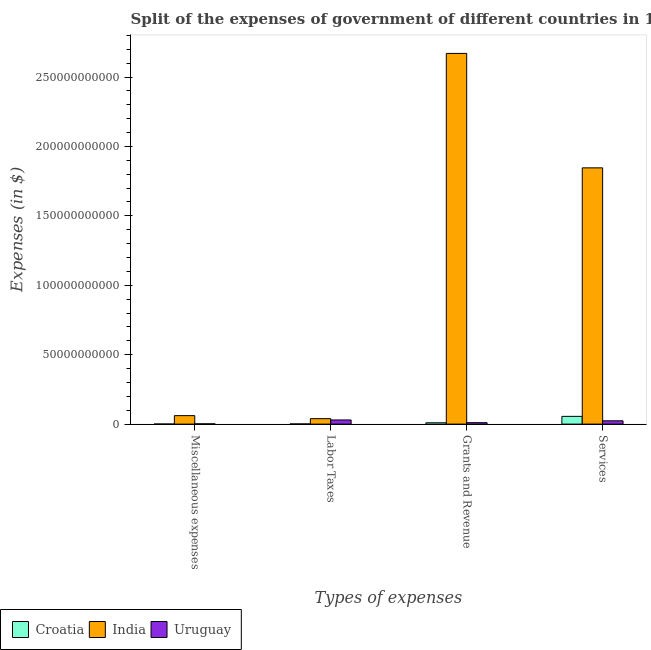How many different coloured bars are there?
Provide a short and direct response. 3. Are the number of bars on each tick of the X-axis equal?
Ensure brevity in your answer.  Yes. How many bars are there on the 1st tick from the right?
Provide a succinct answer. 3. What is the label of the 2nd group of bars from the left?
Provide a short and direct response. Labor Taxes. What is the amount spent on miscellaneous expenses in Uruguay?
Ensure brevity in your answer.  1.96e+08. Across all countries, what is the maximum amount spent on labor taxes?
Your response must be concise. 3.94e+09. Across all countries, what is the minimum amount spent on grants and revenue?
Your answer should be very brief. 9.59e+08. In which country was the amount spent on services minimum?
Your response must be concise. Uruguay. What is the total amount spent on services in the graph?
Offer a very short reply. 1.93e+11. What is the difference between the amount spent on miscellaneous expenses in India and that in Croatia?
Keep it short and to the point. 6.05e+09. What is the difference between the amount spent on services in Croatia and the amount spent on miscellaneous expenses in Uruguay?
Offer a very short reply. 5.39e+09. What is the average amount spent on services per country?
Keep it short and to the point. 6.42e+1. What is the difference between the amount spent on grants and revenue and amount spent on services in Croatia?
Provide a short and direct response. -4.62e+09. What is the ratio of the amount spent on miscellaneous expenses in Croatia to that in India?
Provide a succinct answer. 0.01. Is the amount spent on services in India less than that in Croatia?
Your answer should be very brief. No. Is the difference between the amount spent on services in Croatia and India greater than the difference between the amount spent on miscellaneous expenses in Croatia and India?
Offer a very short reply. No. What is the difference between the highest and the second highest amount spent on grants and revenue?
Your answer should be very brief. 2.66e+11. What is the difference between the highest and the lowest amount spent on labor taxes?
Your answer should be compact. 3.81e+09. In how many countries, is the amount spent on labor taxes greater than the average amount spent on labor taxes taken over all countries?
Keep it short and to the point. 2. Is it the case that in every country, the sum of the amount spent on miscellaneous expenses and amount spent on services is greater than the sum of amount spent on labor taxes and amount spent on grants and revenue?
Your answer should be compact. No. What does the 3rd bar from the left in Miscellaneous expenses represents?
Give a very brief answer. Uruguay. What does the 1st bar from the right in Grants and Revenue represents?
Your answer should be compact. Uruguay. How many bars are there?
Provide a short and direct response. 12. Are all the bars in the graph horizontal?
Make the answer very short. No. What is the difference between two consecutive major ticks on the Y-axis?
Offer a terse response. 5.00e+1. Are the values on the major ticks of Y-axis written in scientific E-notation?
Make the answer very short. No. Where does the legend appear in the graph?
Offer a terse response. Bottom left. How are the legend labels stacked?
Make the answer very short. Horizontal. What is the title of the graph?
Offer a terse response. Split of the expenses of government of different countries in 1993. Does "United Arab Emirates" appear as one of the legend labels in the graph?
Your answer should be very brief. No. What is the label or title of the X-axis?
Offer a terse response. Types of expenses. What is the label or title of the Y-axis?
Your response must be concise. Expenses (in $). What is the Expenses (in $) of Croatia in Miscellaneous expenses?
Ensure brevity in your answer.  5.83e+07. What is the Expenses (in $) of India in Miscellaneous expenses?
Make the answer very short. 6.11e+09. What is the Expenses (in $) of Uruguay in Miscellaneous expenses?
Your answer should be very brief. 1.96e+08. What is the Expenses (in $) of Croatia in Labor Taxes?
Your response must be concise. 1.32e+08. What is the Expenses (in $) of India in Labor Taxes?
Your answer should be compact. 3.94e+09. What is the Expenses (in $) of Uruguay in Labor Taxes?
Keep it short and to the point. 2.99e+09. What is the Expenses (in $) in Croatia in Grants and Revenue?
Give a very brief answer. 9.59e+08. What is the Expenses (in $) in India in Grants and Revenue?
Your answer should be compact. 2.67e+11. What is the Expenses (in $) in Uruguay in Grants and Revenue?
Your answer should be compact. 1.04e+09. What is the Expenses (in $) in Croatia in Services?
Keep it short and to the point. 5.58e+09. What is the Expenses (in $) of India in Services?
Keep it short and to the point. 1.85e+11. What is the Expenses (in $) of Uruguay in Services?
Make the answer very short. 2.38e+09. Across all Types of expenses, what is the maximum Expenses (in $) of Croatia?
Your answer should be very brief. 5.58e+09. Across all Types of expenses, what is the maximum Expenses (in $) in India?
Keep it short and to the point. 2.67e+11. Across all Types of expenses, what is the maximum Expenses (in $) in Uruguay?
Give a very brief answer. 2.99e+09. Across all Types of expenses, what is the minimum Expenses (in $) of Croatia?
Provide a succinct answer. 5.83e+07. Across all Types of expenses, what is the minimum Expenses (in $) in India?
Provide a short and direct response. 3.94e+09. Across all Types of expenses, what is the minimum Expenses (in $) of Uruguay?
Ensure brevity in your answer.  1.96e+08. What is the total Expenses (in $) in Croatia in the graph?
Offer a very short reply. 6.73e+09. What is the total Expenses (in $) of India in the graph?
Ensure brevity in your answer.  4.62e+11. What is the total Expenses (in $) in Uruguay in the graph?
Provide a short and direct response. 6.61e+09. What is the difference between the Expenses (in $) in Croatia in Miscellaneous expenses and that in Labor Taxes?
Ensure brevity in your answer.  -7.38e+07. What is the difference between the Expenses (in $) in India in Miscellaneous expenses and that in Labor Taxes?
Offer a terse response. 2.17e+09. What is the difference between the Expenses (in $) in Uruguay in Miscellaneous expenses and that in Labor Taxes?
Your response must be concise. -2.80e+09. What is the difference between the Expenses (in $) in Croatia in Miscellaneous expenses and that in Grants and Revenue?
Provide a succinct answer. -9.00e+08. What is the difference between the Expenses (in $) in India in Miscellaneous expenses and that in Grants and Revenue?
Your response must be concise. -2.61e+11. What is the difference between the Expenses (in $) in Uruguay in Miscellaneous expenses and that in Grants and Revenue?
Offer a very short reply. -8.44e+08. What is the difference between the Expenses (in $) in Croatia in Miscellaneous expenses and that in Services?
Ensure brevity in your answer.  -5.52e+09. What is the difference between the Expenses (in $) of India in Miscellaneous expenses and that in Services?
Your response must be concise. -1.78e+11. What is the difference between the Expenses (in $) of Uruguay in Miscellaneous expenses and that in Services?
Your answer should be compact. -2.18e+09. What is the difference between the Expenses (in $) of Croatia in Labor Taxes and that in Grants and Revenue?
Provide a succinct answer. -8.27e+08. What is the difference between the Expenses (in $) in India in Labor Taxes and that in Grants and Revenue?
Offer a terse response. -2.63e+11. What is the difference between the Expenses (in $) of Uruguay in Labor Taxes and that in Grants and Revenue?
Give a very brief answer. 1.95e+09. What is the difference between the Expenses (in $) in Croatia in Labor Taxes and that in Services?
Provide a succinct answer. -5.45e+09. What is the difference between the Expenses (in $) in India in Labor Taxes and that in Services?
Your answer should be compact. -1.81e+11. What is the difference between the Expenses (in $) of Uruguay in Labor Taxes and that in Services?
Ensure brevity in your answer.  6.13e+08. What is the difference between the Expenses (in $) in Croatia in Grants and Revenue and that in Services?
Your answer should be very brief. -4.62e+09. What is the difference between the Expenses (in $) of India in Grants and Revenue and that in Services?
Offer a very short reply. 8.24e+1. What is the difference between the Expenses (in $) of Uruguay in Grants and Revenue and that in Services?
Your answer should be very brief. -1.34e+09. What is the difference between the Expenses (in $) of Croatia in Miscellaneous expenses and the Expenses (in $) of India in Labor Taxes?
Ensure brevity in your answer.  -3.88e+09. What is the difference between the Expenses (in $) of Croatia in Miscellaneous expenses and the Expenses (in $) of Uruguay in Labor Taxes?
Provide a short and direct response. -2.94e+09. What is the difference between the Expenses (in $) in India in Miscellaneous expenses and the Expenses (in $) in Uruguay in Labor Taxes?
Your answer should be compact. 3.12e+09. What is the difference between the Expenses (in $) of Croatia in Miscellaneous expenses and the Expenses (in $) of India in Grants and Revenue?
Ensure brevity in your answer.  -2.67e+11. What is the difference between the Expenses (in $) of Croatia in Miscellaneous expenses and the Expenses (in $) of Uruguay in Grants and Revenue?
Ensure brevity in your answer.  -9.82e+08. What is the difference between the Expenses (in $) of India in Miscellaneous expenses and the Expenses (in $) of Uruguay in Grants and Revenue?
Offer a very short reply. 5.07e+09. What is the difference between the Expenses (in $) in Croatia in Miscellaneous expenses and the Expenses (in $) in India in Services?
Provide a succinct answer. -1.85e+11. What is the difference between the Expenses (in $) in Croatia in Miscellaneous expenses and the Expenses (in $) in Uruguay in Services?
Offer a very short reply. -2.32e+09. What is the difference between the Expenses (in $) of India in Miscellaneous expenses and the Expenses (in $) of Uruguay in Services?
Offer a terse response. 3.73e+09. What is the difference between the Expenses (in $) of Croatia in Labor Taxes and the Expenses (in $) of India in Grants and Revenue?
Keep it short and to the point. -2.67e+11. What is the difference between the Expenses (in $) in Croatia in Labor Taxes and the Expenses (in $) in Uruguay in Grants and Revenue?
Keep it short and to the point. -9.08e+08. What is the difference between the Expenses (in $) of India in Labor Taxes and the Expenses (in $) of Uruguay in Grants and Revenue?
Your response must be concise. 2.90e+09. What is the difference between the Expenses (in $) of Croatia in Labor Taxes and the Expenses (in $) of India in Services?
Make the answer very short. -1.84e+11. What is the difference between the Expenses (in $) of Croatia in Labor Taxes and the Expenses (in $) of Uruguay in Services?
Provide a succinct answer. -2.25e+09. What is the difference between the Expenses (in $) of India in Labor Taxes and the Expenses (in $) of Uruguay in Services?
Ensure brevity in your answer.  1.56e+09. What is the difference between the Expenses (in $) of Croatia in Grants and Revenue and the Expenses (in $) of India in Services?
Give a very brief answer. -1.84e+11. What is the difference between the Expenses (in $) of Croatia in Grants and Revenue and the Expenses (in $) of Uruguay in Services?
Your answer should be very brief. -1.42e+09. What is the difference between the Expenses (in $) in India in Grants and Revenue and the Expenses (in $) in Uruguay in Services?
Provide a succinct answer. 2.65e+11. What is the average Expenses (in $) in Croatia per Types of expenses?
Provide a succinct answer. 1.68e+09. What is the average Expenses (in $) of India per Types of expenses?
Keep it short and to the point. 1.15e+11. What is the average Expenses (in $) of Uruguay per Types of expenses?
Keep it short and to the point. 1.65e+09. What is the difference between the Expenses (in $) of Croatia and Expenses (in $) of India in Miscellaneous expenses?
Provide a short and direct response. -6.05e+09. What is the difference between the Expenses (in $) in Croatia and Expenses (in $) in Uruguay in Miscellaneous expenses?
Your answer should be very brief. -1.38e+08. What is the difference between the Expenses (in $) of India and Expenses (in $) of Uruguay in Miscellaneous expenses?
Keep it short and to the point. 5.91e+09. What is the difference between the Expenses (in $) of Croatia and Expenses (in $) of India in Labor Taxes?
Ensure brevity in your answer.  -3.81e+09. What is the difference between the Expenses (in $) of Croatia and Expenses (in $) of Uruguay in Labor Taxes?
Give a very brief answer. -2.86e+09. What is the difference between the Expenses (in $) of India and Expenses (in $) of Uruguay in Labor Taxes?
Your answer should be compact. 9.46e+08. What is the difference between the Expenses (in $) in Croatia and Expenses (in $) in India in Grants and Revenue?
Offer a terse response. -2.66e+11. What is the difference between the Expenses (in $) in Croatia and Expenses (in $) in Uruguay in Grants and Revenue?
Your response must be concise. -8.14e+07. What is the difference between the Expenses (in $) in India and Expenses (in $) in Uruguay in Grants and Revenue?
Keep it short and to the point. 2.66e+11. What is the difference between the Expenses (in $) of Croatia and Expenses (in $) of India in Services?
Ensure brevity in your answer.  -1.79e+11. What is the difference between the Expenses (in $) of Croatia and Expenses (in $) of Uruguay in Services?
Your answer should be very brief. 3.20e+09. What is the difference between the Expenses (in $) in India and Expenses (in $) in Uruguay in Services?
Offer a very short reply. 1.82e+11. What is the ratio of the Expenses (in $) in Croatia in Miscellaneous expenses to that in Labor Taxes?
Make the answer very short. 0.44. What is the ratio of the Expenses (in $) of India in Miscellaneous expenses to that in Labor Taxes?
Your response must be concise. 1.55. What is the ratio of the Expenses (in $) of Uruguay in Miscellaneous expenses to that in Labor Taxes?
Give a very brief answer. 0.07. What is the ratio of the Expenses (in $) of Croatia in Miscellaneous expenses to that in Grants and Revenue?
Your answer should be very brief. 0.06. What is the ratio of the Expenses (in $) in India in Miscellaneous expenses to that in Grants and Revenue?
Provide a short and direct response. 0.02. What is the ratio of the Expenses (in $) of Uruguay in Miscellaneous expenses to that in Grants and Revenue?
Provide a short and direct response. 0.19. What is the ratio of the Expenses (in $) in Croatia in Miscellaneous expenses to that in Services?
Ensure brevity in your answer.  0.01. What is the ratio of the Expenses (in $) of India in Miscellaneous expenses to that in Services?
Provide a short and direct response. 0.03. What is the ratio of the Expenses (in $) in Uruguay in Miscellaneous expenses to that in Services?
Ensure brevity in your answer.  0.08. What is the ratio of the Expenses (in $) in Croatia in Labor Taxes to that in Grants and Revenue?
Provide a succinct answer. 0.14. What is the ratio of the Expenses (in $) of India in Labor Taxes to that in Grants and Revenue?
Keep it short and to the point. 0.01. What is the ratio of the Expenses (in $) of Uruguay in Labor Taxes to that in Grants and Revenue?
Make the answer very short. 2.88. What is the ratio of the Expenses (in $) of Croatia in Labor Taxes to that in Services?
Ensure brevity in your answer.  0.02. What is the ratio of the Expenses (in $) of India in Labor Taxes to that in Services?
Your answer should be compact. 0.02. What is the ratio of the Expenses (in $) in Uruguay in Labor Taxes to that in Services?
Keep it short and to the point. 1.26. What is the ratio of the Expenses (in $) of Croatia in Grants and Revenue to that in Services?
Your answer should be compact. 0.17. What is the ratio of the Expenses (in $) of India in Grants and Revenue to that in Services?
Offer a very short reply. 1.45. What is the ratio of the Expenses (in $) in Uruguay in Grants and Revenue to that in Services?
Offer a terse response. 0.44. What is the difference between the highest and the second highest Expenses (in $) in Croatia?
Your answer should be very brief. 4.62e+09. What is the difference between the highest and the second highest Expenses (in $) of India?
Provide a short and direct response. 8.24e+1. What is the difference between the highest and the second highest Expenses (in $) of Uruguay?
Your answer should be very brief. 6.13e+08. What is the difference between the highest and the lowest Expenses (in $) in Croatia?
Provide a succinct answer. 5.52e+09. What is the difference between the highest and the lowest Expenses (in $) of India?
Your answer should be very brief. 2.63e+11. What is the difference between the highest and the lowest Expenses (in $) in Uruguay?
Make the answer very short. 2.80e+09. 